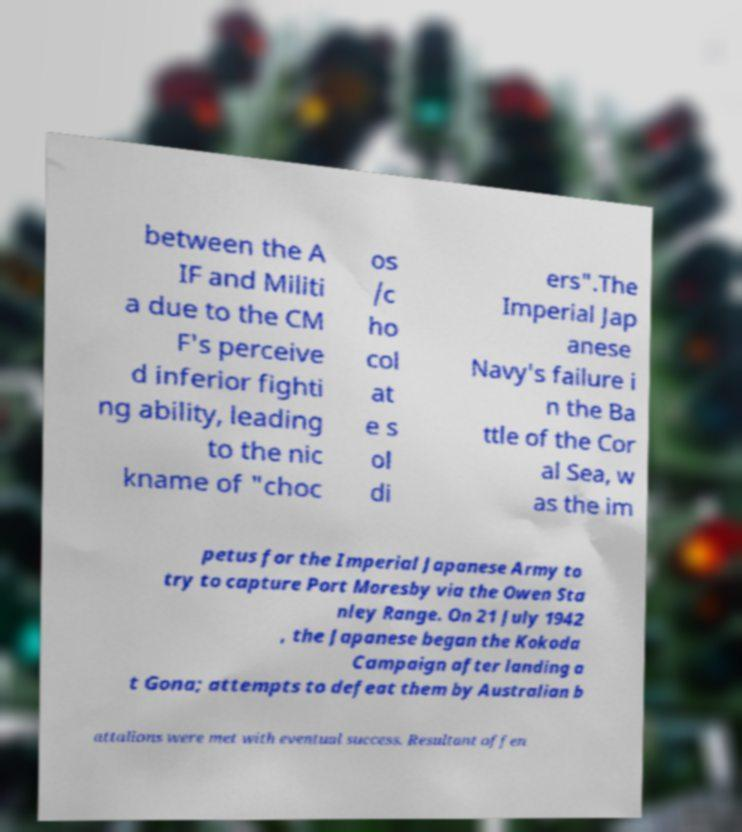Can you read and provide the text displayed in the image?This photo seems to have some interesting text. Can you extract and type it out for me? between the A IF and Militi a due to the CM F's perceive d inferior fighti ng ability, leading to the nic kname of "choc os /c ho col at e s ol di ers".The Imperial Jap anese Navy's failure i n the Ba ttle of the Cor al Sea, w as the im petus for the Imperial Japanese Army to try to capture Port Moresby via the Owen Sta nley Range. On 21 July 1942 , the Japanese began the Kokoda Campaign after landing a t Gona; attempts to defeat them by Australian b attalions were met with eventual success. Resultant offen 